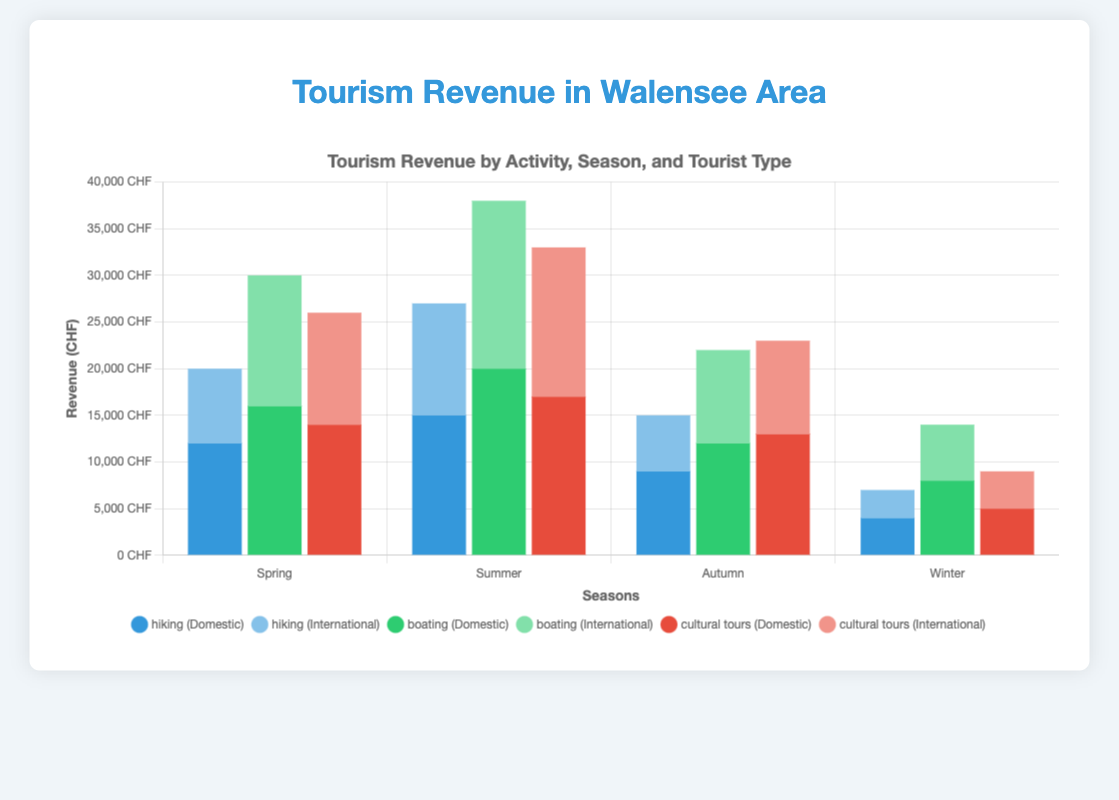Which activity generates the highest revenue during summer from international tourists? Look at the bars representing international tourist revenue for each activity during summer. Boating has the highest bar, indicating it generates the most revenue.
Answer: Boating What is the total revenue from hiking for both domestic and international tourists during winter? Sum the revenue from domestic and international tourists for hiking in winter: 4000 (domestic) + 3000 (international) = 7000 CHF.
Answer: 7000 CHF Which season has the highest total revenue from all activities combined for domestic tourists? Add the heights of bars for domestic tourists across all activities for each season. Summer has the highest total: 15000 (hiking) + 20000 (boating) + 17000 (cultural tours) = 52000 CHF.
Answer: Summer For cultural tours, which season generates more revenue from international tourists than domestic tourists? Compare the international and domestic bars for cultural tours in each season. In summer, international revenue (16000) is higher than domestic revenue (17000).
Answer: Summer What is the difference in boating revenue between domestic and international tourists during autumn? Subtract the international revenue from the domestic revenue for boating in autumn: 12000 (domestic) - 10000 (international) = 2000 CHF.
Answer: 2000 CHF In which season does hiking generate the least revenue for domestic tourists? Look for the shortest bar representing domestic tourist hiking revenue across all seasons. Winter has the shortest bar with 4000 CHF.
Answer: Winter How much total revenue do international tourists generate from all activities during spring? Sum the international revenue for each activity in spring: 8000 (hiking) + 14000 (boating) + 12000 (cultural tours) = 34000 CHF.
Answer: 34000 CHF Which activity has the smallest difference in revenue between domestic and international tourists for winter? Subtract the international revenue from the domestic revenue for each activity in winter and compare the differences. Hiking has the smallest difference: 4000 (domestic) - 3000 (international) = 1000 CHF.
Answer: Hiking 